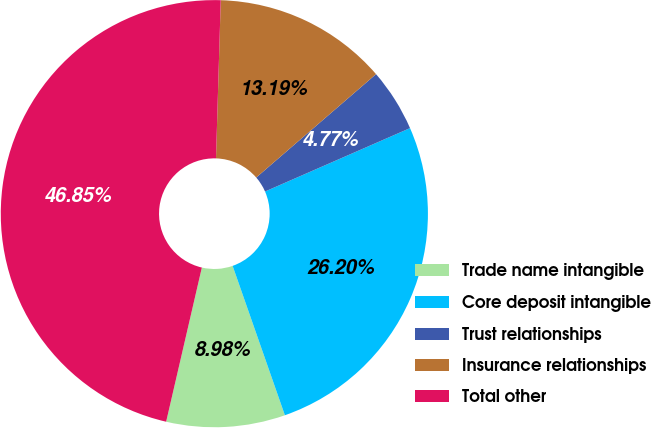<chart> <loc_0><loc_0><loc_500><loc_500><pie_chart><fcel>Trade name intangible<fcel>Core deposit intangible<fcel>Trust relationships<fcel>Insurance relationships<fcel>Total other<nl><fcel>8.98%<fcel>26.2%<fcel>4.77%<fcel>13.19%<fcel>46.85%<nl></chart> 